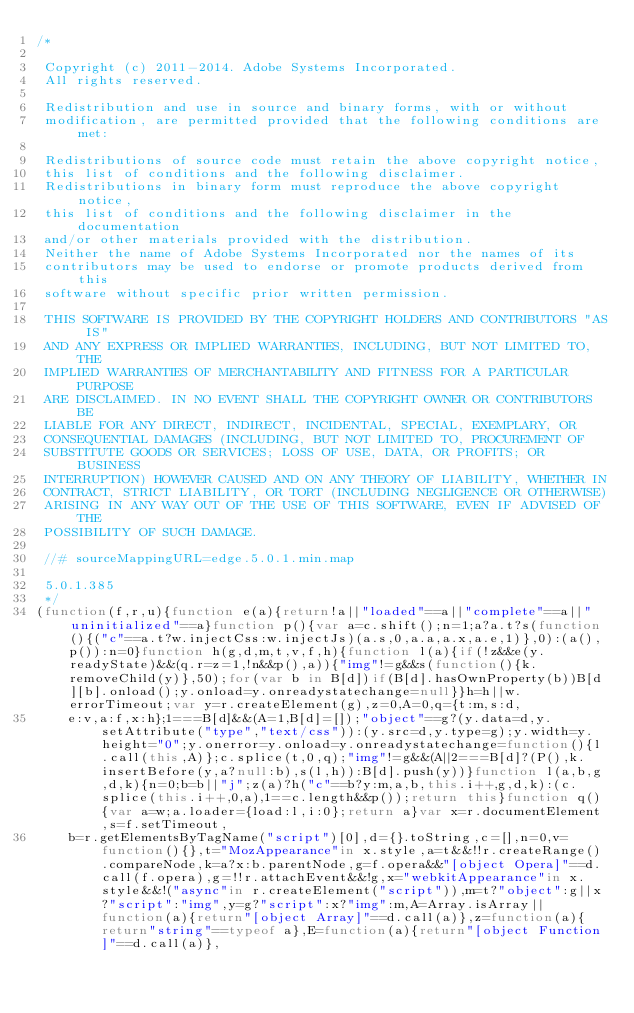Convert code to text. <code><loc_0><loc_0><loc_500><loc_500><_JavaScript_>/*

 Copyright (c) 2011-2014. Adobe Systems Incorporated.
 All rights reserved.

 Redistribution and use in source and binary forms, with or without
 modification, are permitted provided that the following conditions are met:

 Redistributions of source code must retain the above copyright notice,
 this list of conditions and the following disclaimer.
 Redistributions in binary form must reproduce the above copyright notice,
 this list of conditions and the following disclaimer in the documentation
 and/or other materials provided with the distribution.
 Neither the name of Adobe Systems Incorporated nor the names of its
 contributors may be used to endorse or promote products derived from this
 software without specific prior written permission.

 THIS SOFTWARE IS PROVIDED BY THE COPYRIGHT HOLDERS AND CONTRIBUTORS "AS IS"
 AND ANY EXPRESS OR IMPLIED WARRANTIES, INCLUDING, BUT NOT LIMITED TO, THE
 IMPLIED WARRANTIES OF MERCHANTABILITY AND FITNESS FOR A PARTICULAR PURPOSE
 ARE DISCLAIMED. IN NO EVENT SHALL THE COPYRIGHT OWNER OR CONTRIBUTORS BE
 LIABLE FOR ANY DIRECT, INDIRECT, INCIDENTAL, SPECIAL, EXEMPLARY, OR
 CONSEQUENTIAL DAMAGES (INCLUDING, BUT NOT LIMITED TO, PROCUREMENT OF
 SUBSTITUTE GOODS OR SERVICES; LOSS OF USE, DATA, OR PROFITS; OR BUSINESS
 INTERRUPTION) HOWEVER CAUSED AND ON ANY THEORY OF LIABILITY, WHETHER IN
 CONTRACT, STRICT LIABILITY, OR TORT (INCLUDING NEGLIGENCE OR OTHERWISE)
 ARISING IN ANY WAY OUT OF THE USE OF THIS SOFTWARE, EVEN IF ADVISED OF THE
 POSSIBILITY OF SUCH DAMAGE.

 //# sourceMappingURL=edge.5.0.1.min.map

 5.0.1.385
 */
(function(f,r,u){function e(a){return!a||"loaded"==a||"complete"==a||"uninitialized"==a}function p(){var a=c.shift();n=1;a?a.t?s(function(){("c"==a.t?w.injectCss:w.injectJs)(a.s,0,a.a,a.x,a.e,1)},0):(a(),p()):n=0}function h(g,d,m,t,v,f,h){function l(a){if(!z&&e(y.readyState)&&(q.r=z=1,!n&&p(),a)){"img"!=g&&s(function(){k.removeChild(y)},50);for(var b in B[d])if(B[d].hasOwnProperty(b))B[d][b].onload();y.onload=y.onreadystatechange=null}}h=h||w.errorTimeout;var y=r.createElement(g),z=0,A=0,q={t:m,s:d,
    e:v,a:f,x:h};1===B[d]&&(A=1,B[d]=[]);"object"==g?(y.data=d,y.setAttribute("type","text/css")):(y.src=d,y.type=g);y.width=y.height="0";y.onerror=y.onload=y.onreadystatechange=function(){l.call(this,A)};c.splice(t,0,q);"img"!=g&&(A||2===B[d]?(P(),k.insertBefore(y,a?null:b),s(l,h)):B[d].push(y))}function l(a,b,g,d,k){n=0;b=b||"j";z(a)?h("c"==b?y:m,a,b,this.i++,g,d,k):(c.splice(this.i++,0,a),1==c.length&&p());return this}function q(){var a=w;a.loader={load:l,i:0};return a}var x=r.documentElement,s=f.setTimeout,
    b=r.getElementsByTagName("script")[0],d={}.toString,c=[],n=0,v=function(){},t="MozAppearance"in x.style,a=t&&!!r.createRange().compareNode,k=a?x:b.parentNode,g=f.opera&&"[object Opera]"==d.call(f.opera),g=!!r.attachEvent&&!g,x="webkitAppearance"in x.style&&!("async"in r.createElement("script")),m=t?"object":g||x?"script":"img",y=g?"script":x?"img":m,A=Array.isArray||function(a){return"[object Array]"==d.call(a)},z=function(a){return"string"==typeof a},E=function(a){return"[object Function]"==d.call(a)},</code> 